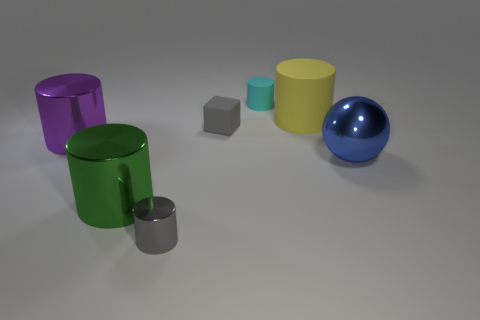There is a block that is the same color as the small shiny cylinder; what size is it?
Your response must be concise. Small. Are there any gray metal cylinders that have the same size as the ball?
Your answer should be compact. No. Is the material of the gray thing that is in front of the blue object the same as the purple cylinder?
Your answer should be very brief. Yes. Are there an equal number of large purple metal objects that are behind the purple metallic object and tiny gray objects behind the green cylinder?
Your response must be concise. No. There is a rubber object that is in front of the cyan rubber cylinder and to the left of the big matte object; what shape is it?
Your answer should be compact. Cube. There is a big green cylinder; what number of large rubber cylinders are left of it?
Your answer should be very brief. 0. How many other objects are the same shape as the big purple thing?
Offer a terse response. 4. Are there fewer tiny rubber objects than tiny gray metal cylinders?
Your answer should be very brief. No. What size is the cylinder that is both left of the large yellow rubber cylinder and behind the big purple cylinder?
Offer a very short reply. Small. There is a gray object behind the small gray thing that is on the left side of the small gray object that is behind the tiny gray cylinder; what size is it?
Keep it short and to the point. Small. 